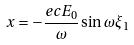<formula> <loc_0><loc_0><loc_500><loc_500>x = - \frac { e c E _ { 0 } } { \omega } \sin \omega \xi _ { 1 }</formula> 